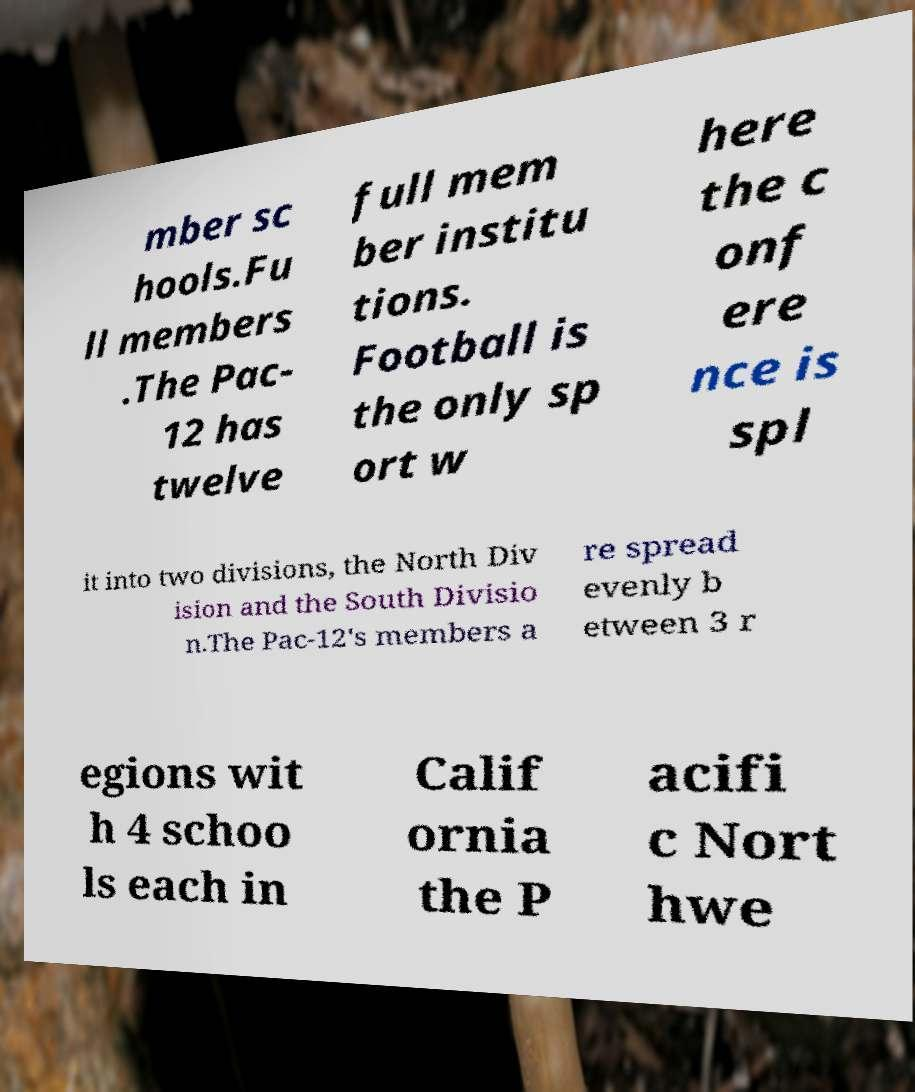What messages or text are displayed in this image? I need them in a readable, typed format. mber sc hools.Fu ll members .The Pac- 12 has twelve full mem ber institu tions. Football is the only sp ort w here the c onf ere nce is spl it into two divisions, the North Div ision and the South Divisio n.The Pac-12's members a re spread evenly b etween 3 r egions wit h 4 schoo ls each in Calif ornia the P acifi c Nort hwe 